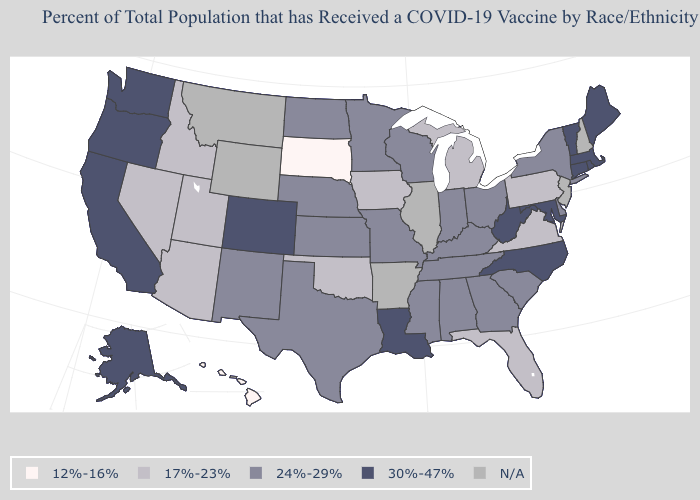Name the states that have a value in the range 24%-29%?
Be succinct. Alabama, Delaware, Georgia, Indiana, Kansas, Kentucky, Minnesota, Mississippi, Missouri, Nebraska, New Mexico, New York, North Dakota, Ohio, South Carolina, Tennessee, Texas, Wisconsin. Among the states that border South Dakota , which have the lowest value?
Be succinct. Iowa. What is the value of New York?
Write a very short answer. 24%-29%. What is the highest value in states that border Montana?
Write a very short answer. 24%-29%. Which states have the lowest value in the Northeast?
Answer briefly. Pennsylvania. How many symbols are there in the legend?
Quick response, please. 5. Which states have the lowest value in the USA?
Quick response, please. Hawaii, South Dakota. What is the value of Wisconsin?
Write a very short answer. 24%-29%. Does Hawaii have the lowest value in the West?
Be succinct. Yes. What is the highest value in the USA?
Concise answer only. 30%-47%. Name the states that have a value in the range 30%-47%?
Be succinct. Alaska, California, Colorado, Connecticut, Louisiana, Maine, Maryland, Massachusetts, North Carolina, Oregon, Rhode Island, Vermont, Washington, West Virginia. Does the map have missing data?
Short answer required. Yes. Name the states that have a value in the range 12%-16%?
Give a very brief answer. Hawaii, South Dakota. 